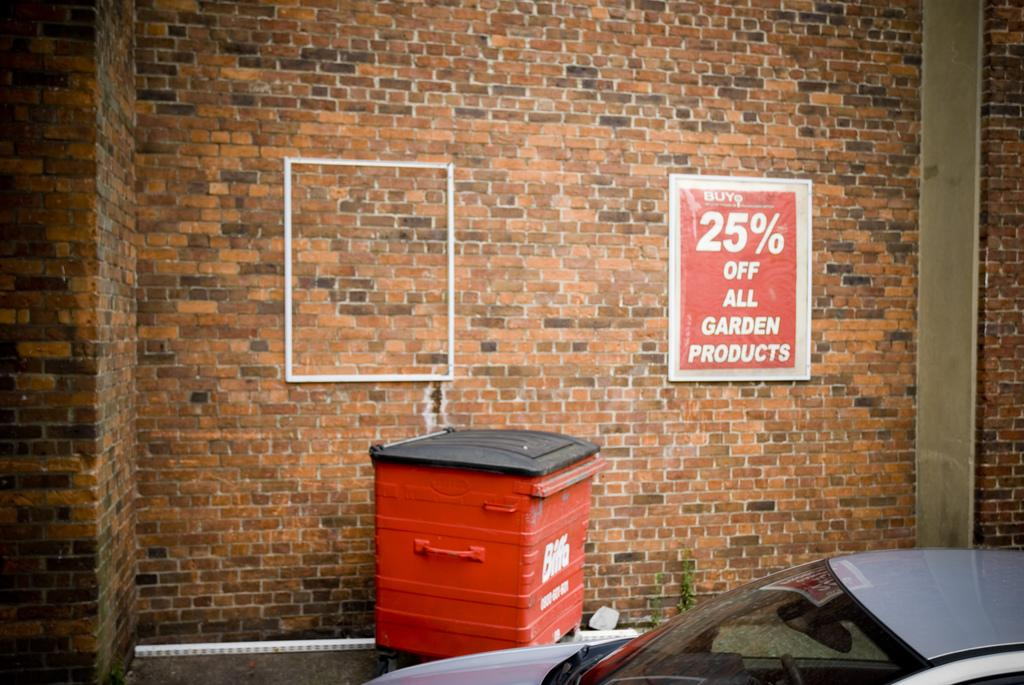What is present on the wall in the image? There is a poster with text on the wall. Can you describe the poster on the wall? The poster on the wall has text, but the specific content is not mentioned in the facts. What is located at the bottom of the image? There is a car at the bottom of the image. What object in the image resembles a container for waste? There is an object that looks like a dustbin in the image. Can you tell me how many rabbits are hopping around the car in the image? There are no rabbits present in the image; it only features a car, a wall with a poster, and an object that resembles a dustbin. What is the cause of the car's presence in the image? The facts provided do not mention the reason or cause for the car's presence in the image. 